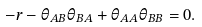Convert formula to latex. <formula><loc_0><loc_0><loc_500><loc_500>- r - \theta _ { A B } \theta _ { B A } + \theta _ { A A } \theta _ { B B } = 0 .</formula> 